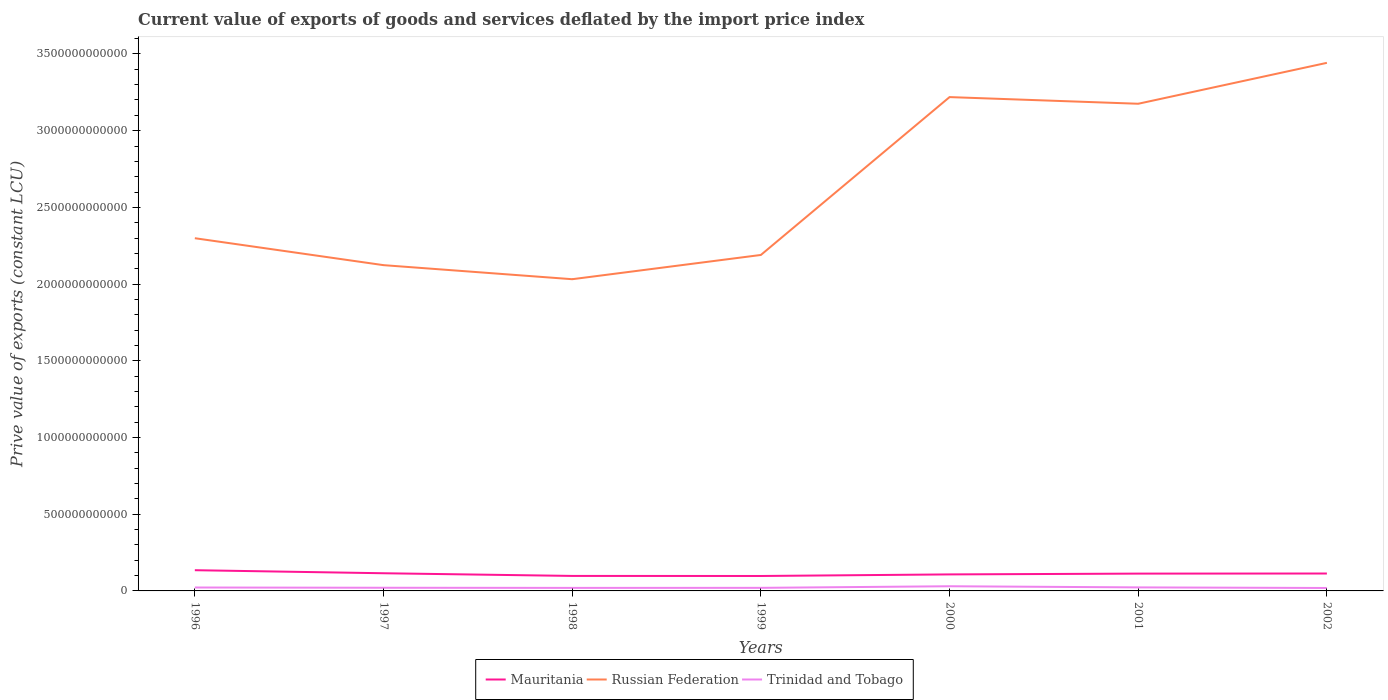Does the line corresponding to Mauritania intersect with the line corresponding to Russian Federation?
Your answer should be very brief. No. Across all years, what is the maximum prive value of exports in Mauritania?
Offer a very short reply. 9.74e+1. What is the total prive value of exports in Trinidad and Tobago in the graph?
Ensure brevity in your answer.  -3.33e+08. What is the difference between the highest and the second highest prive value of exports in Mauritania?
Provide a succinct answer. 3.77e+1. What is the difference between the highest and the lowest prive value of exports in Mauritania?
Offer a terse response. 4. How many lines are there?
Offer a terse response. 3. What is the difference between two consecutive major ticks on the Y-axis?
Provide a succinct answer. 5.00e+11. Are the values on the major ticks of Y-axis written in scientific E-notation?
Offer a terse response. No. Does the graph contain any zero values?
Keep it short and to the point. No. Does the graph contain grids?
Ensure brevity in your answer.  No. How many legend labels are there?
Ensure brevity in your answer.  3. How are the legend labels stacked?
Offer a very short reply. Horizontal. What is the title of the graph?
Your response must be concise. Current value of exports of goods and services deflated by the import price index. What is the label or title of the Y-axis?
Give a very brief answer. Prive value of exports (constant LCU). What is the Prive value of exports (constant LCU) in Mauritania in 1996?
Your response must be concise. 1.35e+11. What is the Prive value of exports (constant LCU) in Russian Federation in 1996?
Make the answer very short. 2.30e+12. What is the Prive value of exports (constant LCU) in Trinidad and Tobago in 1996?
Provide a succinct answer. 2.23e+1. What is the Prive value of exports (constant LCU) of Mauritania in 1997?
Provide a short and direct response. 1.15e+11. What is the Prive value of exports (constant LCU) of Russian Federation in 1997?
Offer a terse response. 2.12e+12. What is the Prive value of exports (constant LCU) of Trinidad and Tobago in 1997?
Keep it short and to the point. 2.07e+1. What is the Prive value of exports (constant LCU) in Mauritania in 1998?
Your answer should be very brief. 9.78e+1. What is the Prive value of exports (constant LCU) in Russian Federation in 1998?
Your response must be concise. 2.03e+12. What is the Prive value of exports (constant LCU) of Trinidad and Tobago in 1998?
Give a very brief answer. 1.97e+1. What is the Prive value of exports (constant LCU) in Mauritania in 1999?
Offer a very short reply. 9.74e+1. What is the Prive value of exports (constant LCU) in Russian Federation in 1999?
Ensure brevity in your answer.  2.19e+12. What is the Prive value of exports (constant LCU) of Trinidad and Tobago in 1999?
Keep it short and to the point. 2.01e+1. What is the Prive value of exports (constant LCU) in Mauritania in 2000?
Your answer should be compact. 1.08e+11. What is the Prive value of exports (constant LCU) in Russian Federation in 2000?
Give a very brief answer. 3.22e+12. What is the Prive value of exports (constant LCU) in Trinidad and Tobago in 2000?
Give a very brief answer. 3.04e+1. What is the Prive value of exports (constant LCU) in Mauritania in 2001?
Ensure brevity in your answer.  1.13e+11. What is the Prive value of exports (constant LCU) in Russian Federation in 2001?
Your response must be concise. 3.18e+12. What is the Prive value of exports (constant LCU) in Trinidad and Tobago in 2001?
Provide a short and direct response. 2.30e+1. What is the Prive value of exports (constant LCU) of Mauritania in 2002?
Provide a short and direct response. 1.14e+11. What is the Prive value of exports (constant LCU) of Russian Federation in 2002?
Offer a terse response. 3.44e+12. What is the Prive value of exports (constant LCU) in Trinidad and Tobago in 2002?
Provide a short and direct response. 1.91e+1. Across all years, what is the maximum Prive value of exports (constant LCU) of Mauritania?
Provide a short and direct response. 1.35e+11. Across all years, what is the maximum Prive value of exports (constant LCU) of Russian Federation?
Ensure brevity in your answer.  3.44e+12. Across all years, what is the maximum Prive value of exports (constant LCU) in Trinidad and Tobago?
Make the answer very short. 3.04e+1. Across all years, what is the minimum Prive value of exports (constant LCU) in Mauritania?
Provide a short and direct response. 9.74e+1. Across all years, what is the minimum Prive value of exports (constant LCU) in Russian Federation?
Offer a very short reply. 2.03e+12. Across all years, what is the minimum Prive value of exports (constant LCU) of Trinidad and Tobago?
Ensure brevity in your answer.  1.91e+1. What is the total Prive value of exports (constant LCU) in Mauritania in the graph?
Your answer should be compact. 7.79e+11. What is the total Prive value of exports (constant LCU) of Russian Federation in the graph?
Provide a succinct answer. 1.85e+13. What is the total Prive value of exports (constant LCU) in Trinidad and Tobago in the graph?
Your response must be concise. 1.55e+11. What is the difference between the Prive value of exports (constant LCU) of Mauritania in 1996 and that in 1997?
Provide a succinct answer. 1.99e+1. What is the difference between the Prive value of exports (constant LCU) of Russian Federation in 1996 and that in 1997?
Provide a short and direct response. 1.76e+11. What is the difference between the Prive value of exports (constant LCU) in Trinidad and Tobago in 1996 and that in 1997?
Offer a very short reply. 1.61e+09. What is the difference between the Prive value of exports (constant LCU) in Mauritania in 1996 and that in 1998?
Ensure brevity in your answer.  3.73e+1. What is the difference between the Prive value of exports (constant LCU) of Russian Federation in 1996 and that in 1998?
Your answer should be very brief. 2.67e+11. What is the difference between the Prive value of exports (constant LCU) of Trinidad and Tobago in 1996 and that in 1998?
Your response must be concise. 2.52e+09. What is the difference between the Prive value of exports (constant LCU) in Mauritania in 1996 and that in 1999?
Make the answer very short. 3.77e+1. What is the difference between the Prive value of exports (constant LCU) of Russian Federation in 1996 and that in 1999?
Give a very brief answer. 1.09e+11. What is the difference between the Prive value of exports (constant LCU) in Trinidad and Tobago in 1996 and that in 1999?
Your answer should be compact. 2.19e+09. What is the difference between the Prive value of exports (constant LCU) in Mauritania in 1996 and that in 2000?
Your answer should be compact. 2.74e+1. What is the difference between the Prive value of exports (constant LCU) of Russian Federation in 1996 and that in 2000?
Ensure brevity in your answer.  -9.20e+11. What is the difference between the Prive value of exports (constant LCU) in Trinidad and Tobago in 1996 and that in 2000?
Make the answer very short. -8.15e+09. What is the difference between the Prive value of exports (constant LCU) of Mauritania in 1996 and that in 2001?
Make the answer very short. 2.22e+1. What is the difference between the Prive value of exports (constant LCU) of Russian Federation in 1996 and that in 2001?
Provide a short and direct response. -8.76e+11. What is the difference between the Prive value of exports (constant LCU) of Trinidad and Tobago in 1996 and that in 2001?
Keep it short and to the point. -7.57e+08. What is the difference between the Prive value of exports (constant LCU) in Mauritania in 1996 and that in 2002?
Offer a terse response. 2.16e+1. What is the difference between the Prive value of exports (constant LCU) of Russian Federation in 1996 and that in 2002?
Make the answer very short. -1.14e+12. What is the difference between the Prive value of exports (constant LCU) in Trinidad and Tobago in 1996 and that in 2002?
Make the answer very short. 3.15e+09. What is the difference between the Prive value of exports (constant LCU) in Mauritania in 1997 and that in 1998?
Offer a very short reply. 1.74e+1. What is the difference between the Prive value of exports (constant LCU) of Russian Federation in 1997 and that in 1998?
Give a very brief answer. 9.16e+1. What is the difference between the Prive value of exports (constant LCU) in Trinidad and Tobago in 1997 and that in 1998?
Offer a very short reply. 9.15e+08. What is the difference between the Prive value of exports (constant LCU) of Mauritania in 1997 and that in 1999?
Offer a very short reply. 1.78e+1. What is the difference between the Prive value of exports (constant LCU) in Russian Federation in 1997 and that in 1999?
Your answer should be compact. -6.64e+1. What is the difference between the Prive value of exports (constant LCU) in Trinidad and Tobago in 1997 and that in 1999?
Offer a terse response. 5.82e+08. What is the difference between the Prive value of exports (constant LCU) in Mauritania in 1997 and that in 2000?
Give a very brief answer. 7.56e+09. What is the difference between the Prive value of exports (constant LCU) in Russian Federation in 1997 and that in 2000?
Your answer should be compact. -1.10e+12. What is the difference between the Prive value of exports (constant LCU) in Trinidad and Tobago in 1997 and that in 2000?
Give a very brief answer. -9.76e+09. What is the difference between the Prive value of exports (constant LCU) of Mauritania in 1997 and that in 2001?
Provide a short and direct response. 2.36e+09. What is the difference between the Prive value of exports (constant LCU) of Russian Federation in 1997 and that in 2001?
Your response must be concise. -1.05e+12. What is the difference between the Prive value of exports (constant LCU) of Trinidad and Tobago in 1997 and that in 2001?
Provide a short and direct response. -2.36e+09. What is the difference between the Prive value of exports (constant LCU) in Mauritania in 1997 and that in 2002?
Provide a succinct answer. 1.70e+09. What is the difference between the Prive value of exports (constant LCU) in Russian Federation in 1997 and that in 2002?
Offer a terse response. -1.32e+12. What is the difference between the Prive value of exports (constant LCU) of Trinidad and Tobago in 1997 and that in 2002?
Give a very brief answer. 1.54e+09. What is the difference between the Prive value of exports (constant LCU) in Mauritania in 1998 and that in 1999?
Your answer should be very brief. 4.01e+08. What is the difference between the Prive value of exports (constant LCU) of Russian Federation in 1998 and that in 1999?
Your answer should be compact. -1.58e+11. What is the difference between the Prive value of exports (constant LCU) of Trinidad and Tobago in 1998 and that in 1999?
Provide a succinct answer. -3.33e+08. What is the difference between the Prive value of exports (constant LCU) in Mauritania in 1998 and that in 2000?
Your response must be concise. -9.84e+09. What is the difference between the Prive value of exports (constant LCU) of Russian Federation in 1998 and that in 2000?
Offer a very short reply. -1.19e+12. What is the difference between the Prive value of exports (constant LCU) of Trinidad and Tobago in 1998 and that in 2000?
Your answer should be very brief. -1.07e+1. What is the difference between the Prive value of exports (constant LCU) of Mauritania in 1998 and that in 2001?
Your answer should be compact. -1.50e+1. What is the difference between the Prive value of exports (constant LCU) of Russian Federation in 1998 and that in 2001?
Your response must be concise. -1.14e+12. What is the difference between the Prive value of exports (constant LCU) of Trinidad and Tobago in 1998 and that in 2001?
Make the answer very short. -3.28e+09. What is the difference between the Prive value of exports (constant LCU) in Mauritania in 1998 and that in 2002?
Keep it short and to the point. -1.57e+1. What is the difference between the Prive value of exports (constant LCU) of Russian Federation in 1998 and that in 2002?
Provide a succinct answer. -1.41e+12. What is the difference between the Prive value of exports (constant LCU) in Trinidad and Tobago in 1998 and that in 2002?
Offer a terse response. 6.26e+08. What is the difference between the Prive value of exports (constant LCU) in Mauritania in 1999 and that in 2000?
Provide a succinct answer. -1.02e+1. What is the difference between the Prive value of exports (constant LCU) of Russian Federation in 1999 and that in 2000?
Your answer should be very brief. -1.03e+12. What is the difference between the Prive value of exports (constant LCU) of Trinidad and Tobago in 1999 and that in 2000?
Offer a terse response. -1.03e+1. What is the difference between the Prive value of exports (constant LCU) of Mauritania in 1999 and that in 2001?
Offer a terse response. -1.54e+1. What is the difference between the Prive value of exports (constant LCU) in Russian Federation in 1999 and that in 2001?
Keep it short and to the point. -9.86e+11. What is the difference between the Prive value of exports (constant LCU) of Trinidad and Tobago in 1999 and that in 2001?
Offer a terse response. -2.94e+09. What is the difference between the Prive value of exports (constant LCU) in Mauritania in 1999 and that in 2002?
Give a very brief answer. -1.61e+1. What is the difference between the Prive value of exports (constant LCU) in Russian Federation in 1999 and that in 2002?
Your answer should be compact. -1.25e+12. What is the difference between the Prive value of exports (constant LCU) of Trinidad and Tobago in 1999 and that in 2002?
Your answer should be compact. 9.59e+08. What is the difference between the Prive value of exports (constant LCU) in Mauritania in 2000 and that in 2001?
Keep it short and to the point. -5.20e+09. What is the difference between the Prive value of exports (constant LCU) of Russian Federation in 2000 and that in 2001?
Provide a succinct answer. 4.35e+1. What is the difference between the Prive value of exports (constant LCU) of Trinidad and Tobago in 2000 and that in 2001?
Ensure brevity in your answer.  7.40e+09. What is the difference between the Prive value of exports (constant LCU) in Mauritania in 2000 and that in 2002?
Ensure brevity in your answer.  -5.87e+09. What is the difference between the Prive value of exports (constant LCU) of Russian Federation in 2000 and that in 2002?
Provide a succinct answer. -2.23e+11. What is the difference between the Prive value of exports (constant LCU) in Trinidad and Tobago in 2000 and that in 2002?
Your answer should be compact. 1.13e+1. What is the difference between the Prive value of exports (constant LCU) in Mauritania in 2001 and that in 2002?
Your answer should be compact. -6.69e+08. What is the difference between the Prive value of exports (constant LCU) in Russian Federation in 2001 and that in 2002?
Offer a very short reply. -2.67e+11. What is the difference between the Prive value of exports (constant LCU) in Trinidad and Tobago in 2001 and that in 2002?
Provide a short and direct response. 3.90e+09. What is the difference between the Prive value of exports (constant LCU) of Mauritania in 1996 and the Prive value of exports (constant LCU) of Russian Federation in 1997?
Make the answer very short. -1.99e+12. What is the difference between the Prive value of exports (constant LCU) in Mauritania in 1996 and the Prive value of exports (constant LCU) in Trinidad and Tobago in 1997?
Provide a succinct answer. 1.14e+11. What is the difference between the Prive value of exports (constant LCU) in Russian Federation in 1996 and the Prive value of exports (constant LCU) in Trinidad and Tobago in 1997?
Give a very brief answer. 2.28e+12. What is the difference between the Prive value of exports (constant LCU) of Mauritania in 1996 and the Prive value of exports (constant LCU) of Russian Federation in 1998?
Make the answer very short. -1.90e+12. What is the difference between the Prive value of exports (constant LCU) in Mauritania in 1996 and the Prive value of exports (constant LCU) in Trinidad and Tobago in 1998?
Your answer should be compact. 1.15e+11. What is the difference between the Prive value of exports (constant LCU) in Russian Federation in 1996 and the Prive value of exports (constant LCU) in Trinidad and Tobago in 1998?
Your answer should be compact. 2.28e+12. What is the difference between the Prive value of exports (constant LCU) of Mauritania in 1996 and the Prive value of exports (constant LCU) of Russian Federation in 1999?
Provide a succinct answer. -2.05e+12. What is the difference between the Prive value of exports (constant LCU) of Mauritania in 1996 and the Prive value of exports (constant LCU) of Trinidad and Tobago in 1999?
Provide a short and direct response. 1.15e+11. What is the difference between the Prive value of exports (constant LCU) of Russian Federation in 1996 and the Prive value of exports (constant LCU) of Trinidad and Tobago in 1999?
Keep it short and to the point. 2.28e+12. What is the difference between the Prive value of exports (constant LCU) of Mauritania in 1996 and the Prive value of exports (constant LCU) of Russian Federation in 2000?
Offer a terse response. -3.08e+12. What is the difference between the Prive value of exports (constant LCU) of Mauritania in 1996 and the Prive value of exports (constant LCU) of Trinidad and Tobago in 2000?
Your answer should be very brief. 1.05e+11. What is the difference between the Prive value of exports (constant LCU) of Russian Federation in 1996 and the Prive value of exports (constant LCU) of Trinidad and Tobago in 2000?
Keep it short and to the point. 2.27e+12. What is the difference between the Prive value of exports (constant LCU) of Mauritania in 1996 and the Prive value of exports (constant LCU) of Russian Federation in 2001?
Provide a succinct answer. -3.04e+12. What is the difference between the Prive value of exports (constant LCU) of Mauritania in 1996 and the Prive value of exports (constant LCU) of Trinidad and Tobago in 2001?
Your answer should be very brief. 1.12e+11. What is the difference between the Prive value of exports (constant LCU) in Russian Federation in 1996 and the Prive value of exports (constant LCU) in Trinidad and Tobago in 2001?
Keep it short and to the point. 2.28e+12. What is the difference between the Prive value of exports (constant LCU) in Mauritania in 1996 and the Prive value of exports (constant LCU) in Russian Federation in 2002?
Offer a terse response. -3.31e+12. What is the difference between the Prive value of exports (constant LCU) in Mauritania in 1996 and the Prive value of exports (constant LCU) in Trinidad and Tobago in 2002?
Provide a short and direct response. 1.16e+11. What is the difference between the Prive value of exports (constant LCU) of Russian Federation in 1996 and the Prive value of exports (constant LCU) of Trinidad and Tobago in 2002?
Your answer should be very brief. 2.28e+12. What is the difference between the Prive value of exports (constant LCU) of Mauritania in 1997 and the Prive value of exports (constant LCU) of Russian Federation in 1998?
Offer a terse response. -1.92e+12. What is the difference between the Prive value of exports (constant LCU) of Mauritania in 1997 and the Prive value of exports (constant LCU) of Trinidad and Tobago in 1998?
Make the answer very short. 9.55e+1. What is the difference between the Prive value of exports (constant LCU) of Russian Federation in 1997 and the Prive value of exports (constant LCU) of Trinidad and Tobago in 1998?
Provide a succinct answer. 2.10e+12. What is the difference between the Prive value of exports (constant LCU) in Mauritania in 1997 and the Prive value of exports (constant LCU) in Russian Federation in 1999?
Your response must be concise. -2.07e+12. What is the difference between the Prive value of exports (constant LCU) of Mauritania in 1997 and the Prive value of exports (constant LCU) of Trinidad and Tobago in 1999?
Offer a terse response. 9.51e+1. What is the difference between the Prive value of exports (constant LCU) in Russian Federation in 1997 and the Prive value of exports (constant LCU) in Trinidad and Tobago in 1999?
Your answer should be compact. 2.10e+12. What is the difference between the Prive value of exports (constant LCU) in Mauritania in 1997 and the Prive value of exports (constant LCU) in Russian Federation in 2000?
Offer a terse response. -3.10e+12. What is the difference between the Prive value of exports (constant LCU) of Mauritania in 1997 and the Prive value of exports (constant LCU) of Trinidad and Tobago in 2000?
Ensure brevity in your answer.  8.48e+1. What is the difference between the Prive value of exports (constant LCU) of Russian Federation in 1997 and the Prive value of exports (constant LCU) of Trinidad and Tobago in 2000?
Offer a very short reply. 2.09e+12. What is the difference between the Prive value of exports (constant LCU) in Mauritania in 1997 and the Prive value of exports (constant LCU) in Russian Federation in 2001?
Keep it short and to the point. -3.06e+12. What is the difference between the Prive value of exports (constant LCU) in Mauritania in 1997 and the Prive value of exports (constant LCU) in Trinidad and Tobago in 2001?
Provide a short and direct response. 9.22e+1. What is the difference between the Prive value of exports (constant LCU) of Russian Federation in 1997 and the Prive value of exports (constant LCU) of Trinidad and Tobago in 2001?
Your answer should be compact. 2.10e+12. What is the difference between the Prive value of exports (constant LCU) in Mauritania in 1997 and the Prive value of exports (constant LCU) in Russian Federation in 2002?
Offer a terse response. -3.33e+12. What is the difference between the Prive value of exports (constant LCU) of Mauritania in 1997 and the Prive value of exports (constant LCU) of Trinidad and Tobago in 2002?
Ensure brevity in your answer.  9.61e+1. What is the difference between the Prive value of exports (constant LCU) of Russian Federation in 1997 and the Prive value of exports (constant LCU) of Trinidad and Tobago in 2002?
Offer a very short reply. 2.10e+12. What is the difference between the Prive value of exports (constant LCU) of Mauritania in 1998 and the Prive value of exports (constant LCU) of Russian Federation in 1999?
Offer a very short reply. -2.09e+12. What is the difference between the Prive value of exports (constant LCU) of Mauritania in 1998 and the Prive value of exports (constant LCU) of Trinidad and Tobago in 1999?
Make the answer very short. 7.77e+1. What is the difference between the Prive value of exports (constant LCU) in Russian Federation in 1998 and the Prive value of exports (constant LCU) in Trinidad and Tobago in 1999?
Ensure brevity in your answer.  2.01e+12. What is the difference between the Prive value of exports (constant LCU) of Mauritania in 1998 and the Prive value of exports (constant LCU) of Russian Federation in 2000?
Ensure brevity in your answer.  -3.12e+12. What is the difference between the Prive value of exports (constant LCU) in Mauritania in 1998 and the Prive value of exports (constant LCU) in Trinidad and Tobago in 2000?
Provide a succinct answer. 6.74e+1. What is the difference between the Prive value of exports (constant LCU) of Russian Federation in 1998 and the Prive value of exports (constant LCU) of Trinidad and Tobago in 2000?
Your response must be concise. 2.00e+12. What is the difference between the Prive value of exports (constant LCU) of Mauritania in 1998 and the Prive value of exports (constant LCU) of Russian Federation in 2001?
Provide a short and direct response. -3.08e+12. What is the difference between the Prive value of exports (constant LCU) in Mauritania in 1998 and the Prive value of exports (constant LCU) in Trinidad and Tobago in 2001?
Provide a succinct answer. 7.48e+1. What is the difference between the Prive value of exports (constant LCU) in Russian Federation in 1998 and the Prive value of exports (constant LCU) in Trinidad and Tobago in 2001?
Provide a succinct answer. 2.01e+12. What is the difference between the Prive value of exports (constant LCU) in Mauritania in 1998 and the Prive value of exports (constant LCU) in Russian Federation in 2002?
Your answer should be compact. -3.34e+12. What is the difference between the Prive value of exports (constant LCU) in Mauritania in 1998 and the Prive value of exports (constant LCU) in Trinidad and Tobago in 2002?
Offer a very short reply. 7.87e+1. What is the difference between the Prive value of exports (constant LCU) in Russian Federation in 1998 and the Prive value of exports (constant LCU) in Trinidad and Tobago in 2002?
Give a very brief answer. 2.01e+12. What is the difference between the Prive value of exports (constant LCU) of Mauritania in 1999 and the Prive value of exports (constant LCU) of Russian Federation in 2000?
Your answer should be compact. -3.12e+12. What is the difference between the Prive value of exports (constant LCU) in Mauritania in 1999 and the Prive value of exports (constant LCU) in Trinidad and Tobago in 2000?
Your answer should be compact. 6.70e+1. What is the difference between the Prive value of exports (constant LCU) in Russian Federation in 1999 and the Prive value of exports (constant LCU) in Trinidad and Tobago in 2000?
Provide a succinct answer. 2.16e+12. What is the difference between the Prive value of exports (constant LCU) of Mauritania in 1999 and the Prive value of exports (constant LCU) of Russian Federation in 2001?
Make the answer very short. -3.08e+12. What is the difference between the Prive value of exports (constant LCU) of Mauritania in 1999 and the Prive value of exports (constant LCU) of Trinidad and Tobago in 2001?
Keep it short and to the point. 7.44e+1. What is the difference between the Prive value of exports (constant LCU) of Russian Federation in 1999 and the Prive value of exports (constant LCU) of Trinidad and Tobago in 2001?
Offer a terse response. 2.17e+12. What is the difference between the Prive value of exports (constant LCU) in Mauritania in 1999 and the Prive value of exports (constant LCU) in Russian Federation in 2002?
Offer a terse response. -3.34e+12. What is the difference between the Prive value of exports (constant LCU) in Mauritania in 1999 and the Prive value of exports (constant LCU) in Trinidad and Tobago in 2002?
Your answer should be very brief. 7.83e+1. What is the difference between the Prive value of exports (constant LCU) of Russian Federation in 1999 and the Prive value of exports (constant LCU) of Trinidad and Tobago in 2002?
Your answer should be very brief. 2.17e+12. What is the difference between the Prive value of exports (constant LCU) in Mauritania in 2000 and the Prive value of exports (constant LCU) in Russian Federation in 2001?
Make the answer very short. -3.07e+12. What is the difference between the Prive value of exports (constant LCU) of Mauritania in 2000 and the Prive value of exports (constant LCU) of Trinidad and Tobago in 2001?
Offer a very short reply. 8.46e+1. What is the difference between the Prive value of exports (constant LCU) of Russian Federation in 2000 and the Prive value of exports (constant LCU) of Trinidad and Tobago in 2001?
Offer a terse response. 3.20e+12. What is the difference between the Prive value of exports (constant LCU) in Mauritania in 2000 and the Prive value of exports (constant LCU) in Russian Federation in 2002?
Offer a very short reply. -3.33e+12. What is the difference between the Prive value of exports (constant LCU) of Mauritania in 2000 and the Prive value of exports (constant LCU) of Trinidad and Tobago in 2002?
Ensure brevity in your answer.  8.85e+1. What is the difference between the Prive value of exports (constant LCU) of Russian Federation in 2000 and the Prive value of exports (constant LCU) of Trinidad and Tobago in 2002?
Provide a short and direct response. 3.20e+12. What is the difference between the Prive value of exports (constant LCU) of Mauritania in 2001 and the Prive value of exports (constant LCU) of Russian Federation in 2002?
Offer a terse response. -3.33e+12. What is the difference between the Prive value of exports (constant LCU) in Mauritania in 2001 and the Prive value of exports (constant LCU) in Trinidad and Tobago in 2002?
Your response must be concise. 9.37e+1. What is the difference between the Prive value of exports (constant LCU) of Russian Federation in 2001 and the Prive value of exports (constant LCU) of Trinidad and Tobago in 2002?
Keep it short and to the point. 3.16e+12. What is the average Prive value of exports (constant LCU) in Mauritania per year?
Ensure brevity in your answer.  1.11e+11. What is the average Prive value of exports (constant LCU) of Russian Federation per year?
Your answer should be compact. 2.64e+12. What is the average Prive value of exports (constant LCU) of Trinidad and Tobago per year?
Your response must be concise. 2.22e+1. In the year 1996, what is the difference between the Prive value of exports (constant LCU) of Mauritania and Prive value of exports (constant LCU) of Russian Federation?
Give a very brief answer. -2.16e+12. In the year 1996, what is the difference between the Prive value of exports (constant LCU) in Mauritania and Prive value of exports (constant LCU) in Trinidad and Tobago?
Provide a short and direct response. 1.13e+11. In the year 1996, what is the difference between the Prive value of exports (constant LCU) in Russian Federation and Prive value of exports (constant LCU) in Trinidad and Tobago?
Provide a short and direct response. 2.28e+12. In the year 1997, what is the difference between the Prive value of exports (constant LCU) of Mauritania and Prive value of exports (constant LCU) of Russian Federation?
Ensure brevity in your answer.  -2.01e+12. In the year 1997, what is the difference between the Prive value of exports (constant LCU) in Mauritania and Prive value of exports (constant LCU) in Trinidad and Tobago?
Offer a very short reply. 9.45e+1. In the year 1997, what is the difference between the Prive value of exports (constant LCU) of Russian Federation and Prive value of exports (constant LCU) of Trinidad and Tobago?
Make the answer very short. 2.10e+12. In the year 1998, what is the difference between the Prive value of exports (constant LCU) in Mauritania and Prive value of exports (constant LCU) in Russian Federation?
Provide a succinct answer. -1.93e+12. In the year 1998, what is the difference between the Prive value of exports (constant LCU) in Mauritania and Prive value of exports (constant LCU) in Trinidad and Tobago?
Provide a short and direct response. 7.81e+1. In the year 1998, what is the difference between the Prive value of exports (constant LCU) of Russian Federation and Prive value of exports (constant LCU) of Trinidad and Tobago?
Give a very brief answer. 2.01e+12. In the year 1999, what is the difference between the Prive value of exports (constant LCU) of Mauritania and Prive value of exports (constant LCU) of Russian Federation?
Provide a succinct answer. -2.09e+12. In the year 1999, what is the difference between the Prive value of exports (constant LCU) of Mauritania and Prive value of exports (constant LCU) of Trinidad and Tobago?
Your answer should be compact. 7.73e+1. In the year 1999, what is the difference between the Prive value of exports (constant LCU) in Russian Federation and Prive value of exports (constant LCU) in Trinidad and Tobago?
Ensure brevity in your answer.  2.17e+12. In the year 2000, what is the difference between the Prive value of exports (constant LCU) in Mauritania and Prive value of exports (constant LCU) in Russian Federation?
Your answer should be very brief. -3.11e+12. In the year 2000, what is the difference between the Prive value of exports (constant LCU) of Mauritania and Prive value of exports (constant LCU) of Trinidad and Tobago?
Provide a short and direct response. 7.72e+1. In the year 2000, what is the difference between the Prive value of exports (constant LCU) of Russian Federation and Prive value of exports (constant LCU) of Trinidad and Tobago?
Keep it short and to the point. 3.19e+12. In the year 2001, what is the difference between the Prive value of exports (constant LCU) in Mauritania and Prive value of exports (constant LCU) in Russian Federation?
Offer a very short reply. -3.06e+12. In the year 2001, what is the difference between the Prive value of exports (constant LCU) of Mauritania and Prive value of exports (constant LCU) of Trinidad and Tobago?
Your answer should be very brief. 8.98e+1. In the year 2001, what is the difference between the Prive value of exports (constant LCU) in Russian Federation and Prive value of exports (constant LCU) in Trinidad and Tobago?
Your answer should be compact. 3.15e+12. In the year 2002, what is the difference between the Prive value of exports (constant LCU) in Mauritania and Prive value of exports (constant LCU) in Russian Federation?
Offer a terse response. -3.33e+12. In the year 2002, what is the difference between the Prive value of exports (constant LCU) of Mauritania and Prive value of exports (constant LCU) of Trinidad and Tobago?
Offer a very short reply. 9.44e+1. In the year 2002, what is the difference between the Prive value of exports (constant LCU) of Russian Federation and Prive value of exports (constant LCU) of Trinidad and Tobago?
Provide a succinct answer. 3.42e+12. What is the ratio of the Prive value of exports (constant LCU) in Mauritania in 1996 to that in 1997?
Offer a terse response. 1.17. What is the ratio of the Prive value of exports (constant LCU) in Russian Federation in 1996 to that in 1997?
Ensure brevity in your answer.  1.08. What is the ratio of the Prive value of exports (constant LCU) of Trinidad and Tobago in 1996 to that in 1997?
Provide a succinct answer. 1.08. What is the ratio of the Prive value of exports (constant LCU) of Mauritania in 1996 to that in 1998?
Your answer should be compact. 1.38. What is the ratio of the Prive value of exports (constant LCU) in Russian Federation in 1996 to that in 1998?
Give a very brief answer. 1.13. What is the ratio of the Prive value of exports (constant LCU) in Trinidad and Tobago in 1996 to that in 1998?
Your answer should be very brief. 1.13. What is the ratio of the Prive value of exports (constant LCU) of Mauritania in 1996 to that in 1999?
Your answer should be very brief. 1.39. What is the ratio of the Prive value of exports (constant LCU) of Russian Federation in 1996 to that in 1999?
Your answer should be very brief. 1.05. What is the ratio of the Prive value of exports (constant LCU) in Trinidad and Tobago in 1996 to that in 1999?
Your answer should be very brief. 1.11. What is the ratio of the Prive value of exports (constant LCU) in Mauritania in 1996 to that in 2000?
Provide a succinct answer. 1.25. What is the ratio of the Prive value of exports (constant LCU) of Russian Federation in 1996 to that in 2000?
Offer a very short reply. 0.71. What is the ratio of the Prive value of exports (constant LCU) of Trinidad and Tobago in 1996 to that in 2000?
Make the answer very short. 0.73. What is the ratio of the Prive value of exports (constant LCU) in Mauritania in 1996 to that in 2001?
Provide a short and direct response. 1.2. What is the ratio of the Prive value of exports (constant LCU) of Russian Federation in 1996 to that in 2001?
Your answer should be very brief. 0.72. What is the ratio of the Prive value of exports (constant LCU) in Trinidad and Tobago in 1996 to that in 2001?
Your answer should be very brief. 0.97. What is the ratio of the Prive value of exports (constant LCU) in Mauritania in 1996 to that in 2002?
Your response must be concise. 1.19. What is the ratio of the Prive value of exports (constant LCU) of Russian Federation in 1996 to that in 2002?
Give a very brief answer. 0.67. What is the ratio of the Prive value of exports (constant LCU) in Trinidad and Tobago in 1996 to that in 2002?
Keep it short and to the point. 1.16. What is the ratio of the Prive value of exports (constant LCU) of Mauritania in 1997 to that in 1998?
Your response must be concise. 1.18. What is the ratio of the Prive value of exports (constant LCU) in Russian Federation in 1997 to that in 1998?
Ensure brevity in your answer.  1.05. What is the ratio of the Prive value of exports (constant LCU) in Trinidad and Tobago in 1997 to that in 1998?
Provide a succinct answer. 1.05. What is the ratio of the Prive value of exports (constant LCU) in Mauritania in 1997 to that in 1999?
Offer a terse response. 1.18. What is the ratio of the Prive value of exports (constant LCU) in Russian Federation in 1997 to that in 1999?
Offer a very short reply. 0.97. What is the ratio of the Prive value of exports (constant LCU) of Mauritania in 1997 to that in 2000?
Give a very brief answer. 1.07. What is the ratio of the Prive value of exports (constant LCU) in Russian Federation in 1997 to that in 2000?
Provide a short and direct response. 0.66. What is the ratio of the Prive value of exports (constant LCU) of Trinidad and Tobago in 1997 to that in 2000?
Provide a succinct answer. 0.68. What is the ratio of the Prive value of exports (constant LCU) of Russian Federation in 1997 to that in 2001?
Your answer should be very brief. 0.67. What is the ratio of the Prive value of exports (constant LCU) in Trinidad and Tobago in 1997 to that in 2001?
Keep it short and to the point. 0.9. What is the ratio of the Prive value of exports (constant LCU) of Mauritania in 1997 to that in 2002?
Your answer should be very brief. 1.01. What is the ratio of the Prive value of exports (constant LCU) in Russian Federation in 1997 to that in 2002?
Give a very brief answer. 0.62. What is the ratio of the Prive value of exports (constant LCU) in Trinidad and Tobago in 1997 to that in 2002?
Your answer should be compact. 1.08. What is the ratio of the Prive value of exports (constant LCU) of Russian Federation in 1998 to that in 1999?
Provide a short and direct response. 0.93. What is the ratio of the Prive value of exports (constant LCU) of Trinidad and Tobago in 1998 to that in 1999?
Ensure brevity in your answer.  0.98. What is the ratio of the Prive value of exports (constant LCU) of Mauritania in 1998 to that in 2000?
Your answer should be compact. 0.91. What is the ratio of the Prive value of exports (constant LCU) in Russian Federation in 1998 to that in 2000?
Offer a very short reply. 0.63. What is the ratio of the Prive value of exports (constant LCU) in Trinidad and Tobago in 1998 to that in 2000?
Your answer should be very brief. 0.65. What is the ratio of the Prive value of exports (constant LCU) in Mauritania in 1998 to that in 2001?
Provide a short and direct response. 0.87. What is the ratio of the Prive value of exports (constant LCU) of Russian Federation in 1998 to that in 2001?
Provide a short and direct response. 0.64. What is the ratio of the Prive value of exports (constant LCU) in Trinidad and Tobago in 1998 to that in 2001?
Make the answer very short. 0.86. What is the ratio of the Prive value of exports (constant LCU) in Mauritania in 1998 to that in 2002?
Offer a terse response. 0.86. What is the ratio of the Prive value of exports (constant LCU) in Russian Federation in 1998 to that in 2002?
Your response must be concise. 0.59. What is the ratio of the Prive value of exports (constant LCU) of Trinidad and Tobago in 1998 to that in 2002?
Provide a short and direct response. 1.03. What is the ratio of the Prive value of exports (constant LCU) of Mauritania in 1999 to that in 2000?
Keep it short and to the point. 0.9. What is the ratio of the Prive value of exports (constant LCU) in Russian Federation in 1999 to that in 2000?
Your answer should be very brief. 0.68. What is the ratio of the Prive value of exports (constant LCU) in Trinidad and Tobago in 1999 to that in 2000?
Make the answer very short. 0.66. What is the ratio of the Prive value of exports (constant LCU) of Mauritania in 1999 to that in 2001?
Your response must be concise. 0.86. What is the ratio of the Prive value of exports (constant LCU) of Russian Federation in 1999 to that in 2001?
Provide a succinct answer. 0.69. What is the ratio of the Prive value of exports (constant LCU) in Trinidad and Tobago in 1999 to that in 2001?
Give a very brief answer. 0.87. What is the ratio of the Prive value of exports (constant LCU) in Mauritania in 1999 to that in 2002?
Give a very brief answer. 0.86. What is the ratio of the Prive value of exports (constant LCU) in Russian Federation in 1999 to that in 2002?
Provide a succinct answer. 0.64. What is the ratio of the Prive value of exports (constant LCU) in Trinidad and Tobago in 1999 to that in 2002?
Provide a short and direct response. 1.05. What is the ratio of the Prive value of exports (constant LCU) in Mauritania in 2000 to that in 2001?
Give a very brief answer. 0.95. What is the ratio of the Prive value of exports (constant LCU) in Russian Federation in 2000 to that in 2001?
Your answer should be very brief. 1.01. What is the ratio of the Prive value of exports (constant LCU) in Trinidad and Tobago in 2000 to that in 2001?
Offer a terse response. 1.32. What is the ratio of the Prive value of exports (constant LCU) of Mauritania in 2000 to that in 2002?
Provide a succinct answer. 0.95. What is the ratio of the Prive value of exports (constant LCU) in Russian Federation in 2000 to that in 2002?
Ensure brevity in your answer.  0.94. What is the ratio of the Prive value of exports (constant LCU) of Trinidad and Tobago in 2000 to that in 2002?
Your response must be concise. 1.59. What is the ratio of the Prive value of exports (constant LCU) of Mauritania in 2001 to that in 2002?
Your response must be concise. 0.99. What is the ratio of the Prive value of exports (constant LCU) of Russian Federation in 2001 to that in 2002?
Ensure brevity in your answer.  0.92. What is the ratio of the Prive value of exports (constant LCU) in Trinidad and Tobago in 2001 to that in 2002?
Your answer should be compact. 1.2. What is the difference between the highest and the second highest Prive value of exports (constant LCU) of Mauritania?
Provide a short and direct response. 1.99e+1. What is the difference between the highest and the second highest Prive value of exports (constant LCU) of Russian Federation?
Offer a very short reply. 2.23e+11. What is the difference between the highest and the second highest Prive value of exports (constant LCU) of Trinidad and Tobago?
Provide a short and direct response. 7.40e+09. What is the difference between the highest and the lowest Prive value of exports (constant LCU) in Mauritania?
Keep it short and to the point. 3.77e+1. What is the difference between the highest and the lowest Prive value of exports (constant LCU) of Russian Federation?
Your answer should be compact. 1.41e+12. What is the difference between the highest and the lowest Prive value of exports (constant LCU) in Trinidad and Tobago?
Give a very brief answer. 1.13e+1. 